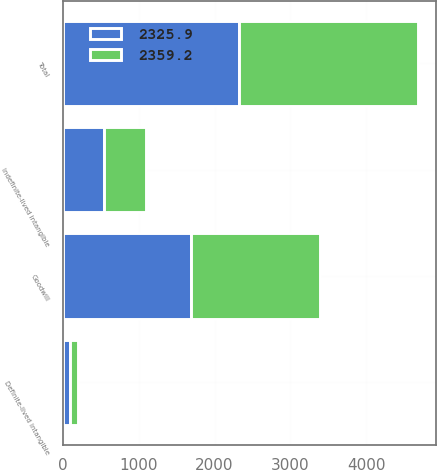<chart> <loc_0><loc_0><loc_500><loc_500><stacked_bar_chart><ecel><fcel>Goodwill<fcel>Indefinite-lived intangible<fcel>Definite-lived intangible<fcel>Total<nl><fcel>2325.9<fcel>1691<fcel>547.4<fcel>87.5<fcel>2325.9<nl><fcel>2359.2<fcel>1701.5<fcel>548.6<fcel>109.1<fcel>2359.2<nl></chart> 